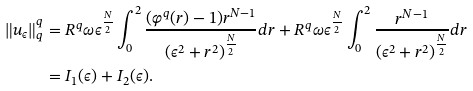<formula> <loc_0><loc_0><loc_500><loc_500>\| u _ { \epsilon } \| _ { q } ^ { q } & = R ^ { q } \omega \epsilon ^ { \frac { N } { 2 } } \int _ { 0 } ^ { 2 } \frac { ( \varphi ^ { q } ( r ) - 1 ) r ^ { N - 1 } } { ( \epsilon ^ { 2 } + r ^ { 2 } ) ^ { \frac { N } { 2 } } } d r + R ^ { q } \omega \epsilon ^ { \frac { N } { 2 } } \int _ { 0 } ^ { 2 } \frac { r ^ { N - 1 } } { ( \epsilon ^ { 2 } + r ^ { 2 } ) ^ { \frac { N } { 2 } } } d r \\ & = I _ { 1 } ( \epsilon ) + I _ { 2 } ( \epsilon ) . \\</formula> 